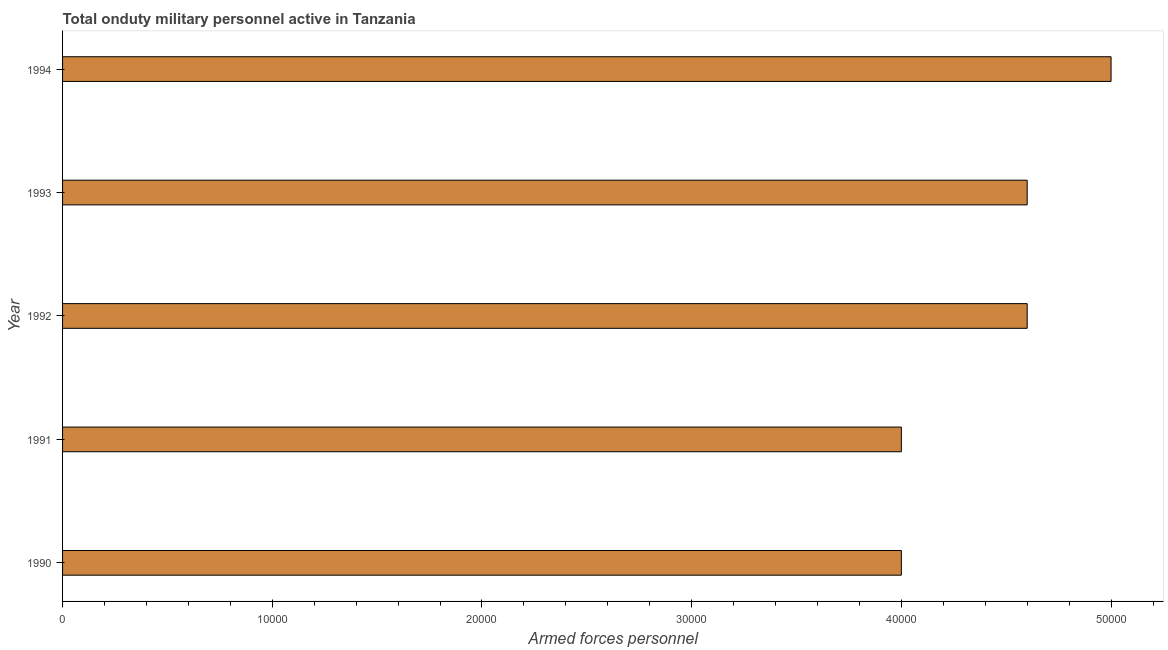Does the graph contain any zero values?
Your answer should be very brief. No. What is the title of the graph?
Your response must be concise. Total onduty military personnel active in Tanzania. What is the label or title of the X-axis?
Your answer should be compact. Armed forces personnel. What is the number of armed forces personnel in 1994?
Provide a short and direct response. 5.00e+04. Across all years, what is the maximum number of armed forces personnel?
Make the answer very short. 5.00e+04. Across all years, what is the minimum number of armed forces personnel?
Make the answer very short. 4.00e+04. In which year was the number of armed forces personnel minimum?
Ensure brevity in your answer.  1990. What is the sum of the number of armed forces personnel?
Your answer should be compact. 2.22e+05. What is the difference between the number of armed forces personnel in 1991 and 1993?
Keep it short and to the point. -6000. What is the average number of armed forces personnel per year?
Your answer should be very brief. 4.44e+04. What is the median number of armed forces personnel?
Your response must be concise. 4.60e+04. In how many years, is the number of armed forces personnel greater than 22000 ?
Ensure brevity in your answer.  5. What is the ratio of the number of armed forces personnel in 1990 to that in 1993?
Offer a very short reply. 0.87. Is the number of armed forces personnel in 1991 less than that in 1992?
Keep it short and to the point. Yes. What is the difference between the highest and the second highest number of armed forces personnel?
Your answer should be very brief. 4000. Is the sum of the number of armed forces personnel in 1991 and 1993 greater than the maximum number of armed forces personnel across all years?
Keep it short and to the point. Yes. What is the difference between the highest and the lowest number of armed forces personnel?
Provide a short and direct response. 10000. In how many years, is the number of armed forces personnel greater than the average number of armed forces personnel taken over all years?
Provide a succinct answer. 3. How many bars are there?
Provide a succinct answer. 5. What is the Armed forces personnel in 1991?
Your answer should be very brief. 4.00e+04. What is the Armed forces personnel of 1992?
Offer a very short reply. 4.60e+04. What is the Armed forces personnel in 1993?
Your response must be concise. 4.60e+04. What is the difference between the Armed forces personnel in 1990 and 1992?
Give a very brief answer. -6000. What is the difference between the Armed forces personnel in 1990 and 1993?
Make the answer very short. -6000. What is the difference between the Armed forces personnel in 1990 and 1994?
Provide a short and direct response. -10000. What is the difference between the Armed forces personnel in 1991 and 1992?
Ensure brevity in your answer.  -6000. What is the difference between the Armed forces personnel in 1991 and 1993?
Give a very brief answer. -6000. What is the difference between the Armed forces personnel in 1992 and 1993?
Keep it short and to the point. 0. What is the difference between the Armed forces personnel in 1992 and 1994?
Your response must be concise. -4000. What is the difference between the Armed forces personnel in 1993 and 1994?
Offer a very short reply. -4000. What is the ratio of the Armed forces personnel in 1990 to that in 1991?
Offer a terse response. 1. What is the ratio of the Armed forces personnel in 1990 to that in 1992?
Your response must be concise. 0.87. What is the ratio of the Armed forces personnel in 1990 to that in 1993?
Keep it short and to the point. 0.87. What is the ratio of the Armed forces personnel in 1991 to that in 1992?
Ensure brevity in your answer.  0.87. What is the ratio of the Armed forces personnel in 1991 to that in 1993?
Ensure brevity in your answer.  0.87. What is the ratio of the Armed forces personnel in 1993 to that in 1994?
Provide a succinct answer. 0.92. 